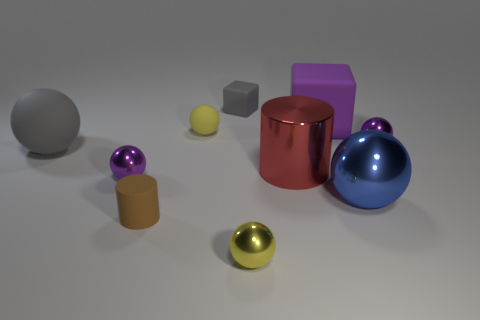What materials are represented by the objects in the image, and how do they interact with the light? The image showcases various objects with different materials including matte, rubber, and metallic finishes. The rubber objects have a softer look with diffused reflections, while the metallic ones have sharp, clear reflections indicating a shiny surface that interacts strongly with the light source, creating distinct highlights and shadows. 